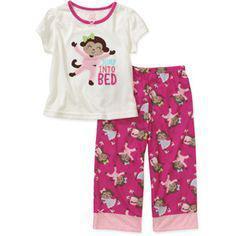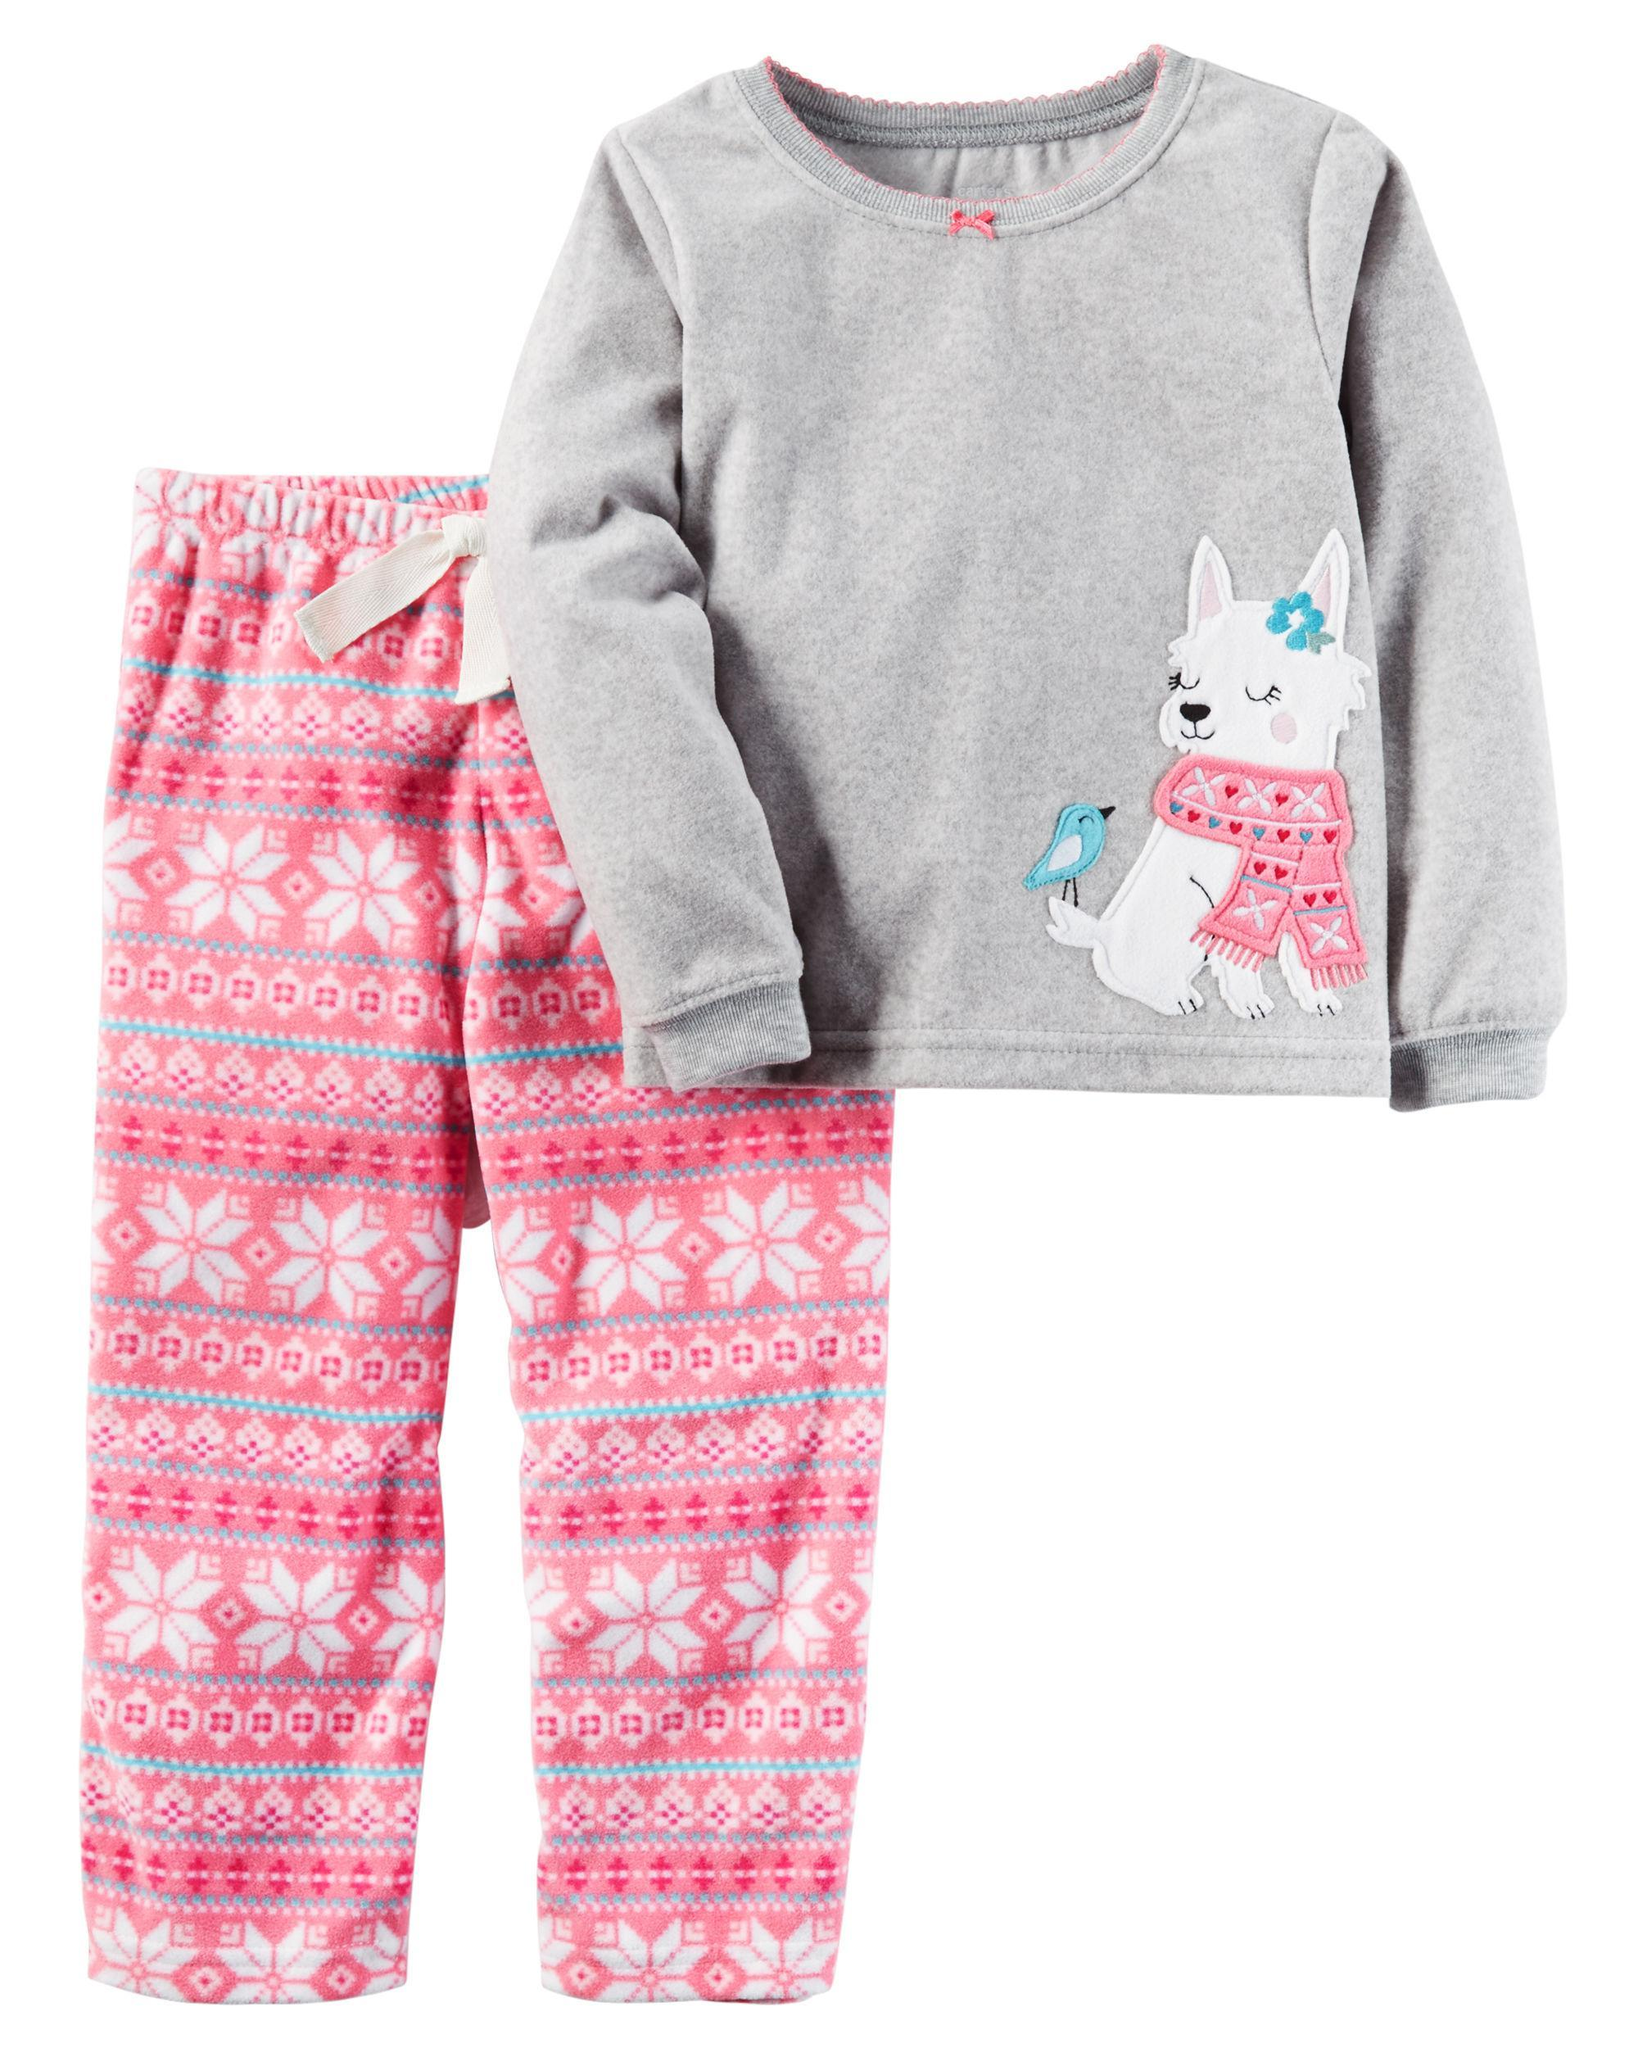The first image is the image on the left, the second image is the image on the right. Examine the images to the left and right. Is the description "There is 1 or more woman modeling pajama's." accurate? Answer yes or no. No. 